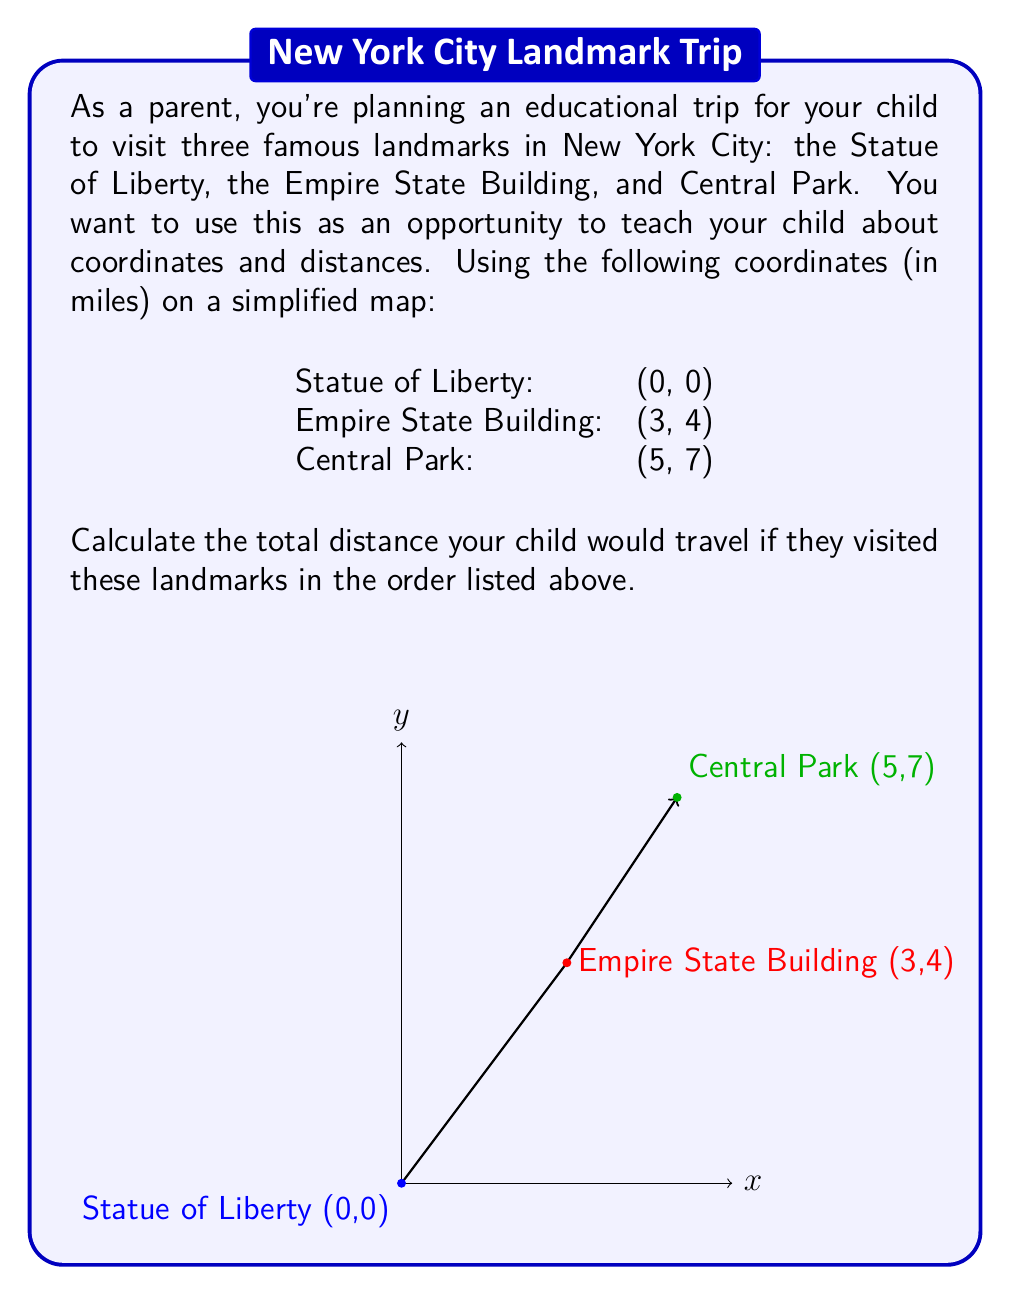What is the answer to this math problem? Let's approach this step-by-step:

1) We need to calculate the distance between each pair of consecutive landmarks and then sum these distances.

2) To calculate the distance between two points, we use the distance formula:
   $$d = \sqrt{(x_2-x_1)^2 + (y_2-y_1)^2}$$

3) First, let's calculate the distance from the Statue of Liberty (0,0) to the Empire State Building (3,4):
   $$d_1 = \sqrt{(3-0)^2 + (4-0)^2} = \sqrt{9 + 16} = \sqrt{25} = 5 \text{ miles}$$

4) Now, let's calculate the distance from the Empire State Building (3,4) to Central Park (5,7):
   $$d_2 = \sqrt{(5-3)^2 + (7-4)^2} = \sqrt{2^2 + 3^2} = \sqrt{4 + 9} = \sqrt{13} \approx 3.61 \text{ miles}$$

5) The total distance is the sum of these two distances:
   $$\text{Total Distance} = d_1 + d_2 = 5 + \sqrt{13} \approx 5 + 3.61 = 8.61 \text{ miles}$$

6) Rounding to two decimal places, we get 8.61 miles.

This exercise demonstrates how coordinates can be used to calculate real-world distances, making it both educational and practical for your child.
Answer: 8.61 miles 